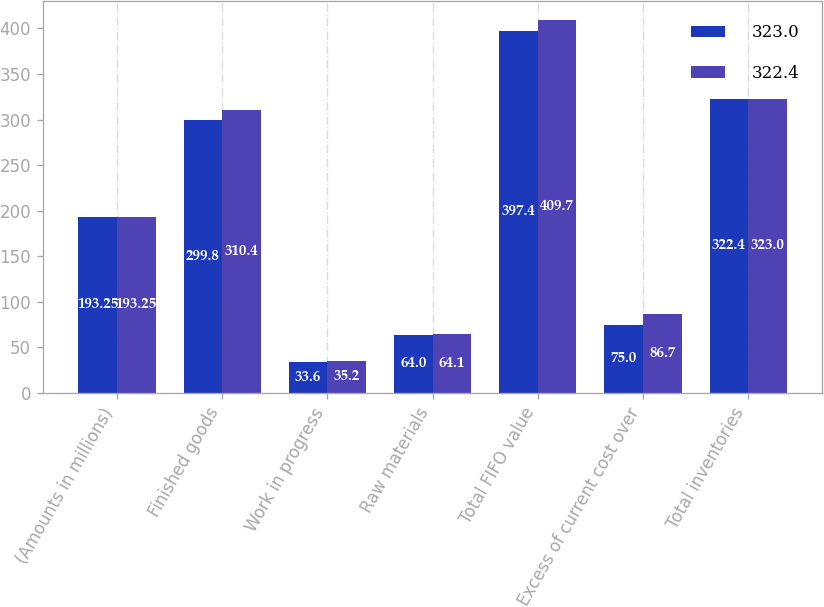Convert chart. <chart><loc_0><loc_0><loc_500><loc_500><stacked_bar_chart><ecel><fcel>(Amounts in millions)<fcel>Finished goods<fcel>Work in progress<fcel>Raw materials<fcel>Total FIFO value<fcel>Excess of current cost over<fcel>Total inventories<nl><fcel>323<fcel>193.25<fcel>299.8<fcel>33.6<fcel>64<fcel>397.4<fcel>75<fcel>322.4<nl><fcel>322.4<fcel>193.25<fcel>310.4<fcel>35.2<fcel>64.1<fcel>409.7<fcel>86.7<fcel>323<nl></chart> 